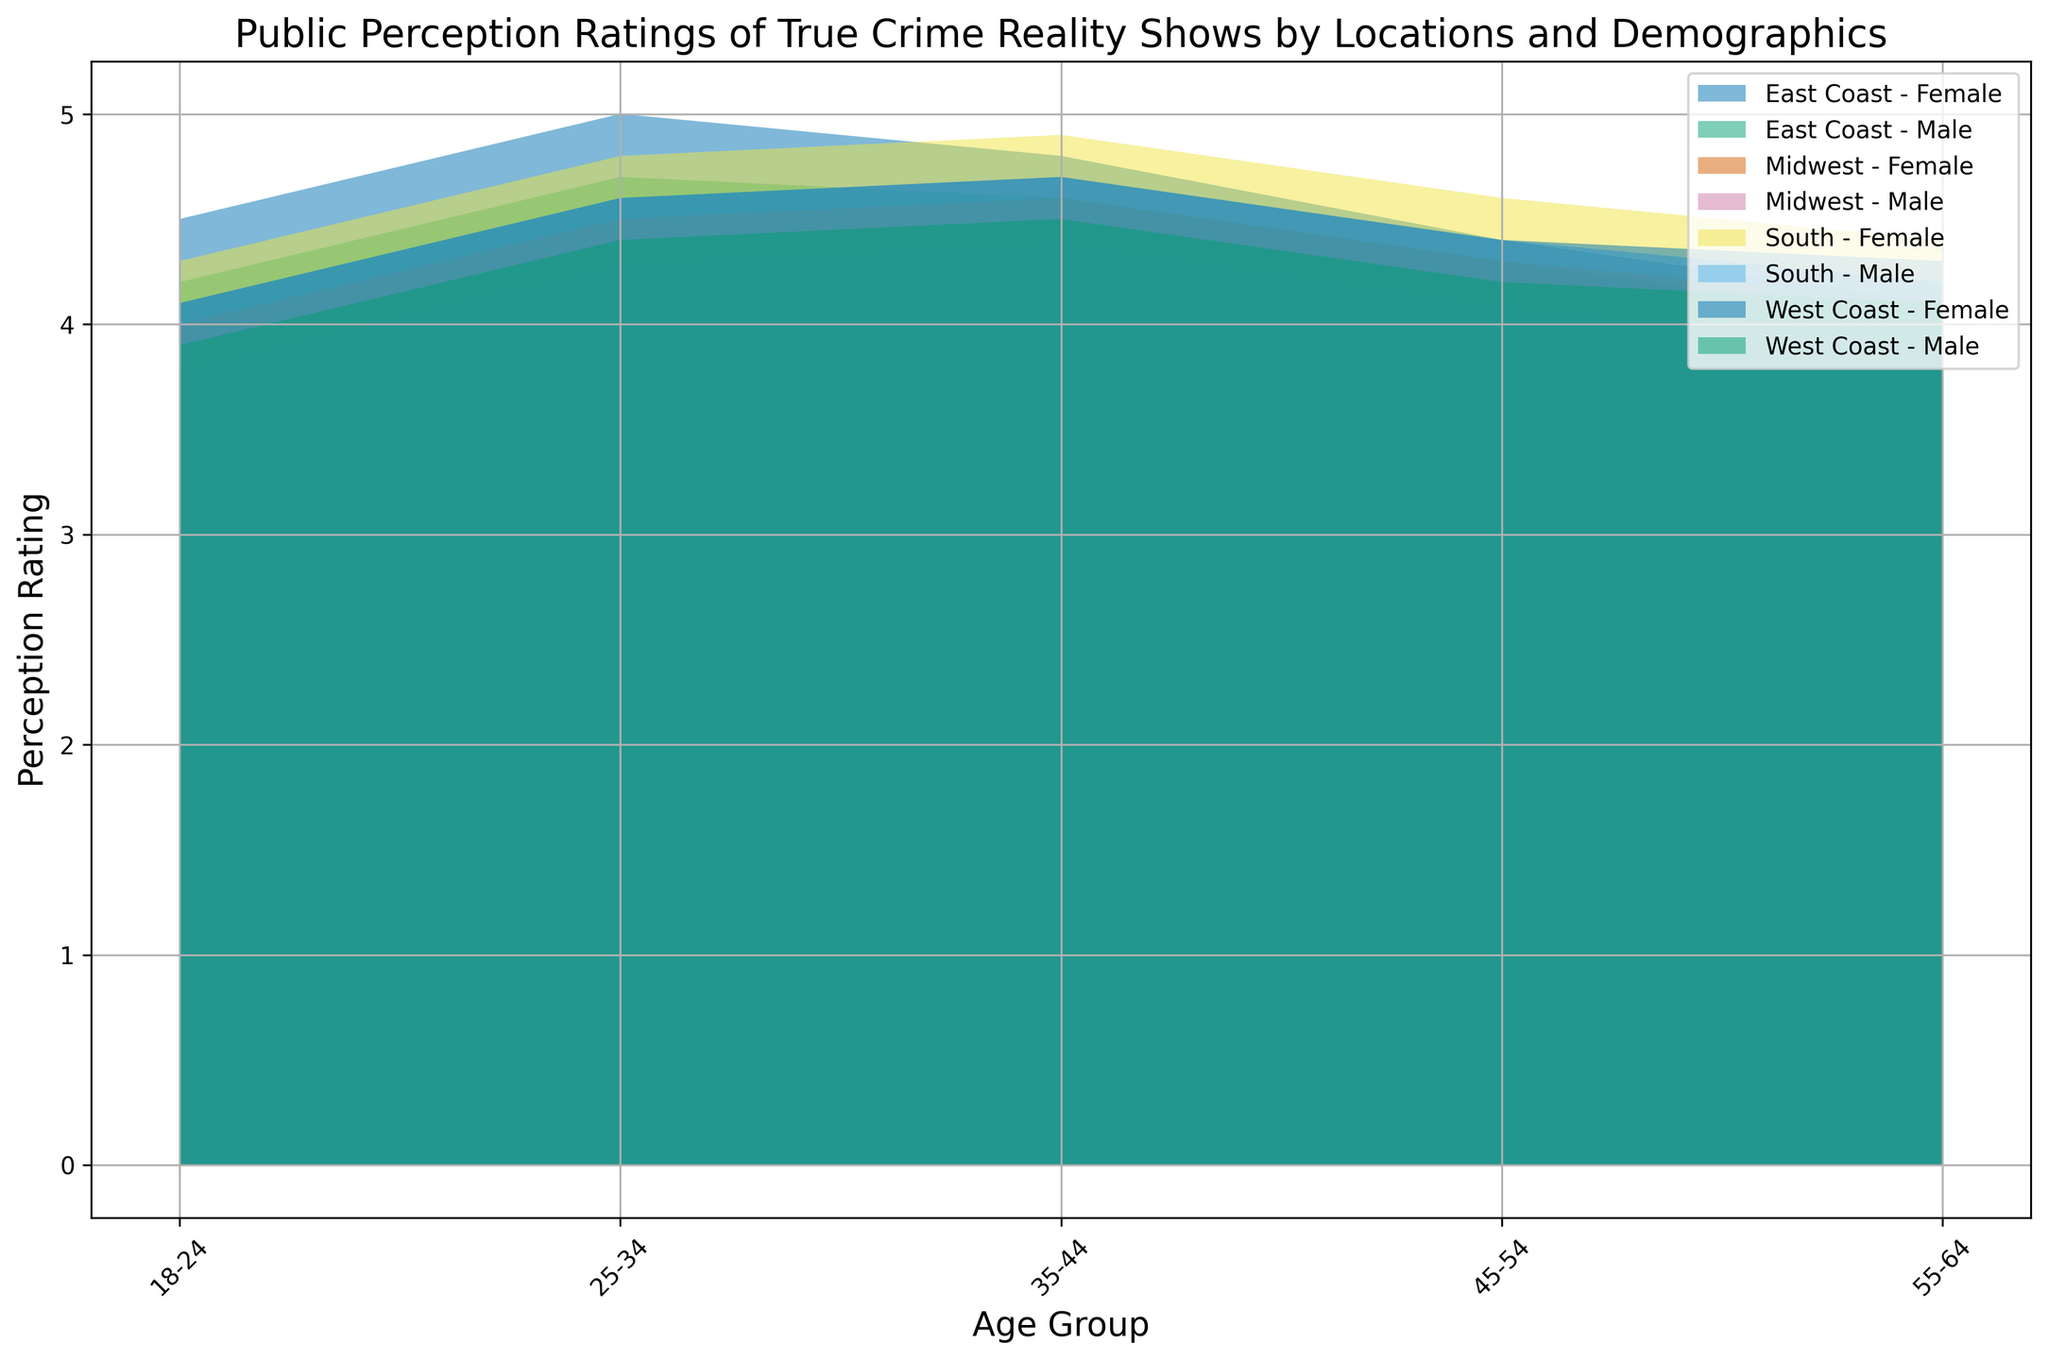Which location and gender have the highest perception rating for the age group 25-34? By observing the height of the filled areas in the age group 25-34, the East Coast-Female group's area is the highest.
Answer: East Coast-Female What's the difference in perception ratings between East Coast-Male and West Coast-Male in the age group 45-54? For East Coast-Male in the 45-54 age group, the rating is 4.3. For West Coast-Male in the same age group, the rating is 4.2. The difference is 4.3 - 4.2 = 0.1.
Answer: 0.1 Which gender has higher perception ratings generally across all locations for the age group 35-44? For the age group 35-44, the filled areas for females are generally higher across all locations compared to males, indicating higher perception ratings for females.
Answer: Female What is the average perception rating for the Midwest-18-24 across both genders? The perception rating for Midwest-18-24 Male is 3.8 and for Female is 4.0. The average is (3.8 + 4.0) / 2 = 3.9.
Answer: 3.9 Which age group has the lowest perception rating in the Midwest, regardless of gender? For the Midwest, regardless of gender, the age group 55-64 has the lowest perception ratings. The filled areas are lowest in this age group.
Answer: 55-64 Is the perception rating for South-Female higher or lower than West Coast-Male in the age group 25-34? For South-Female in the 25-34 age group, the perception rating is 4.8. For West Coast-Male, the rating is 4.4. South-Female's rating is higher.
Answer: Higher Compare the perception ratings of East Coast-Female and South-Female in the age group 55-64. For 55-64, East Coast-Female has a perception rating of 4.1 and South-Female has 4.4. South-Female's perception is higher.
Answer: South-Female What is the range of perception ratings for West Coast-Male across all age groups? The perception ratings for West Coast-Male are 3.9 (18-24), 4.4 (25-34), 4.5 (35-44), 4.2 (45-54), and 4.1 (55-64). The range is 4.5 - 3.9 = 0.6.
Answer: 0.6 